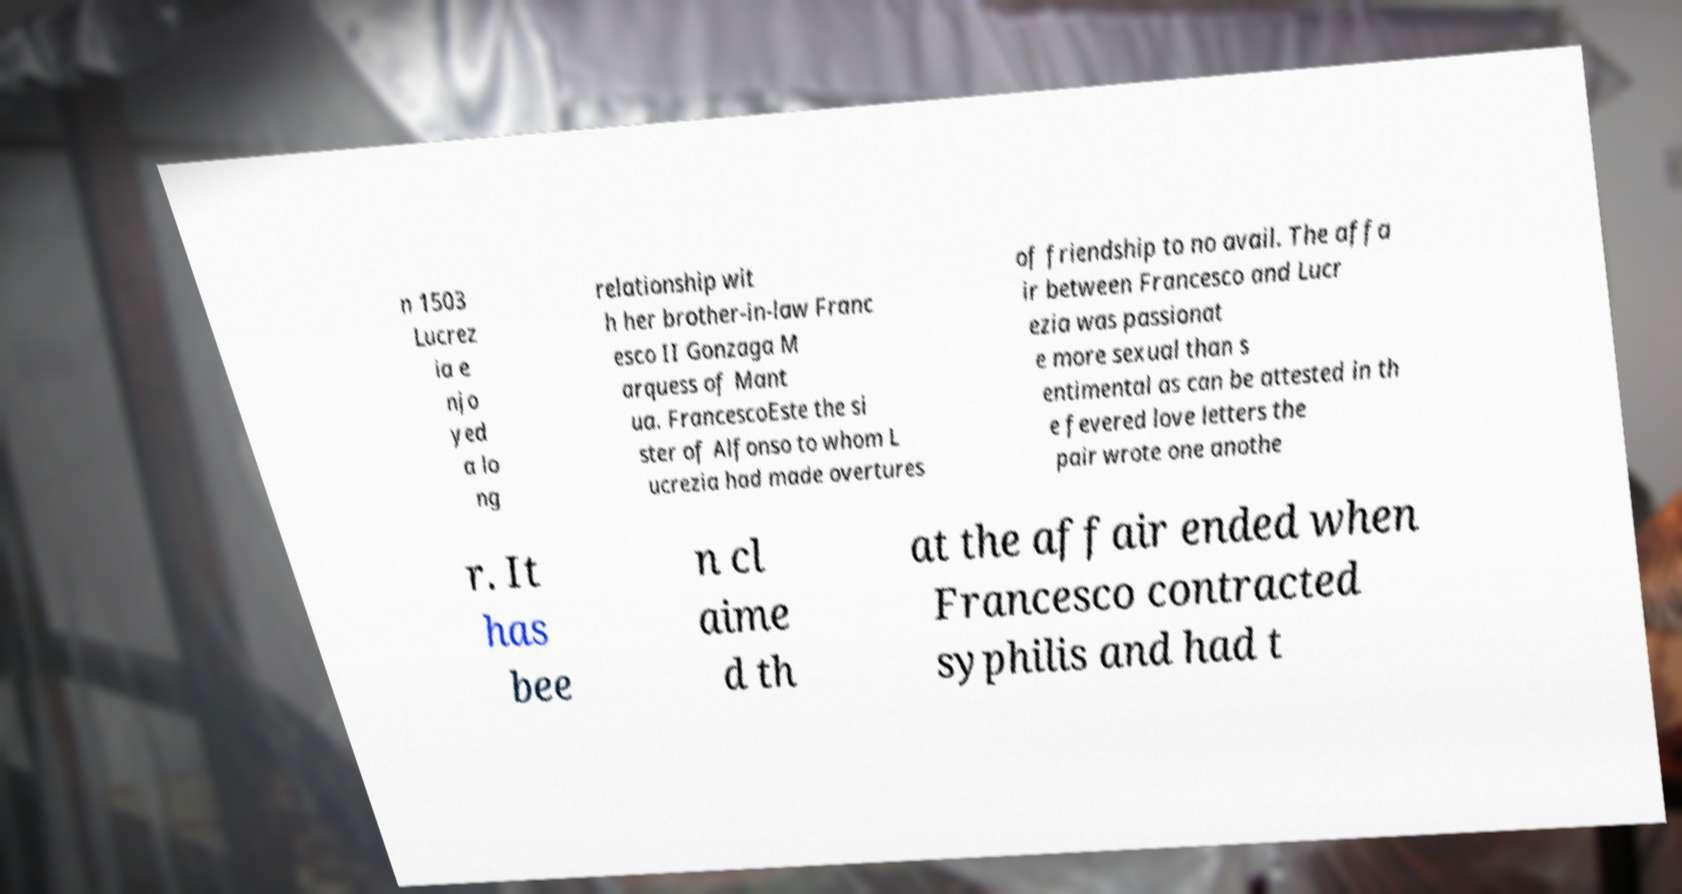For documentation purposes, I need the text within this image transcribed. Could you provide that? n 1503 Lucrez ia e njo yed a lo ng relationship wit h her brother-in-law Franc esco II Gonzaga M arquess of Mant ua. FrancescoEste the si ster of Alfonso to whom L ucrezia had made overtures of friendship to no avail. The affa ir between Francesco and Lucr ezia was passionat e more sexual than s entimental as can be attested in th e fevered love letters the pair wrote one anothe r. It has bee n cl aime d th at the affair ended when Francesco contracted syphilis and had t 